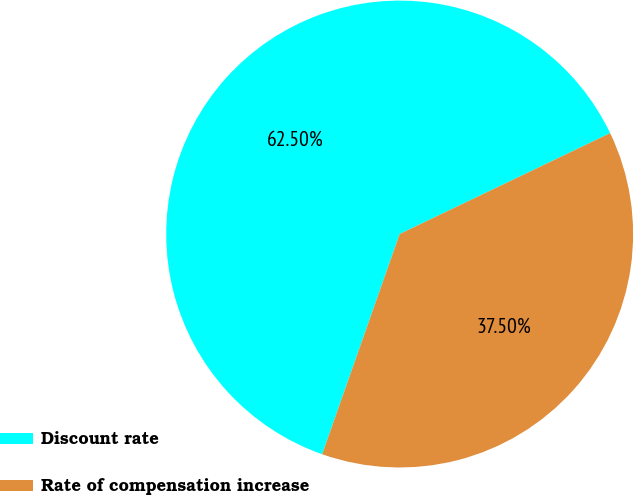<chart> <loc_0><loc_0><loc_500><loc_500><pie_chart><fcel>Discount rate<fcel>Rate of compensation increase<nl><fcel>62.5%<fcel>37.5%<nl></chart> 